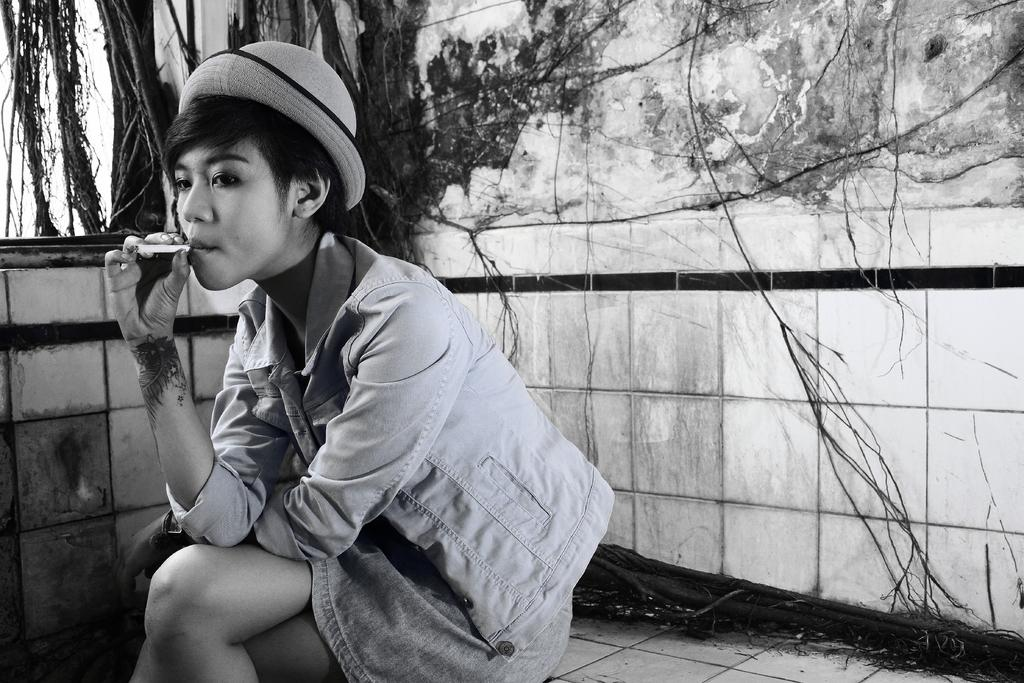What is the person in the image doing? The person is sitting on the floor. What is the person wearing in the image? The person is wearing a jacket. What is the person holding in the image? The person is holding a cigarette. What can be seen in the background of the image? There are tree stems visible in the background of the image. What type of drink is the person holding in the image? The person is not holding a drink in the image; they are holding a cigarette. Can you see a nest in the image? There is no nest present in the image; only tree stems are visible in the background. 